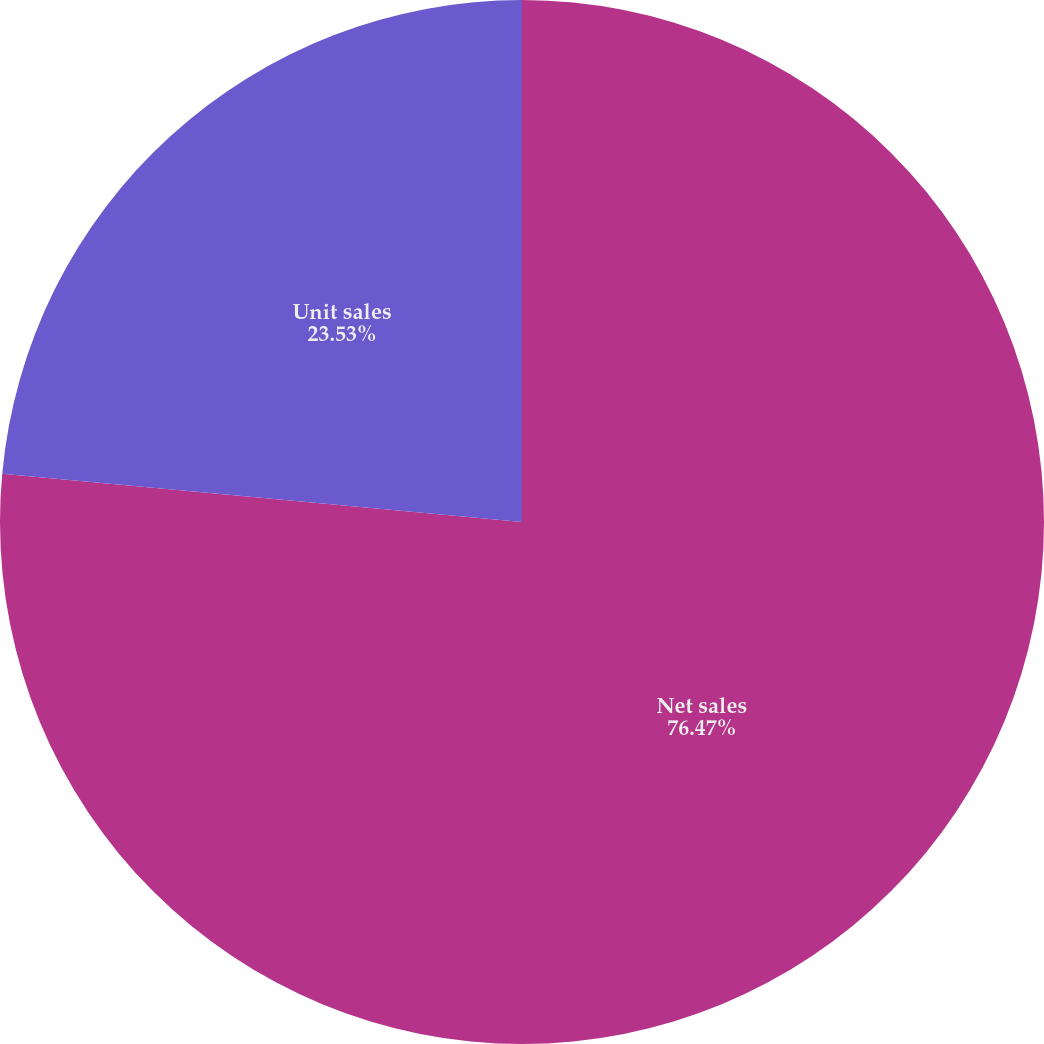Convert chart. <chart><loc_0><loc_0><loc_500><loc_500><pie_chart><fcel>Net sales<fcel>Unit sales<nl><fcel>76.47%<fcel>23.53%<nl></chart> 